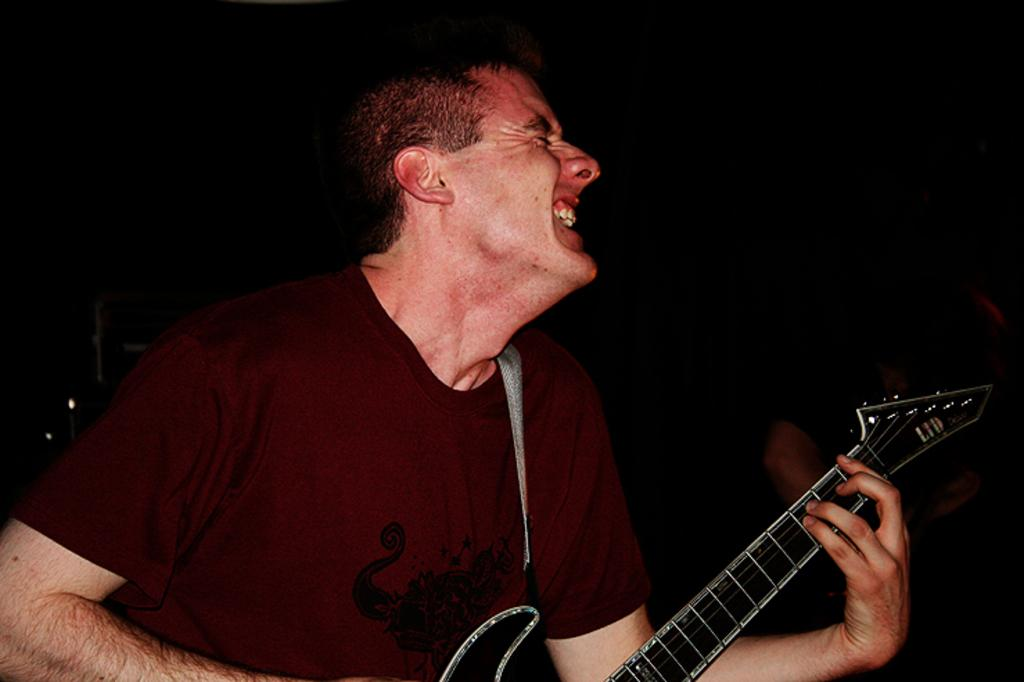What is the man in the image doing? The man is playing the guitar in the image. What type of clothing is the man wearing? The man is wearing a T-shirt in the image. How many letters are visible on the man's T-shirt in the image? There is no information provided about letters on the man's T-shirt, so we cannot determine how many letters are visible. 